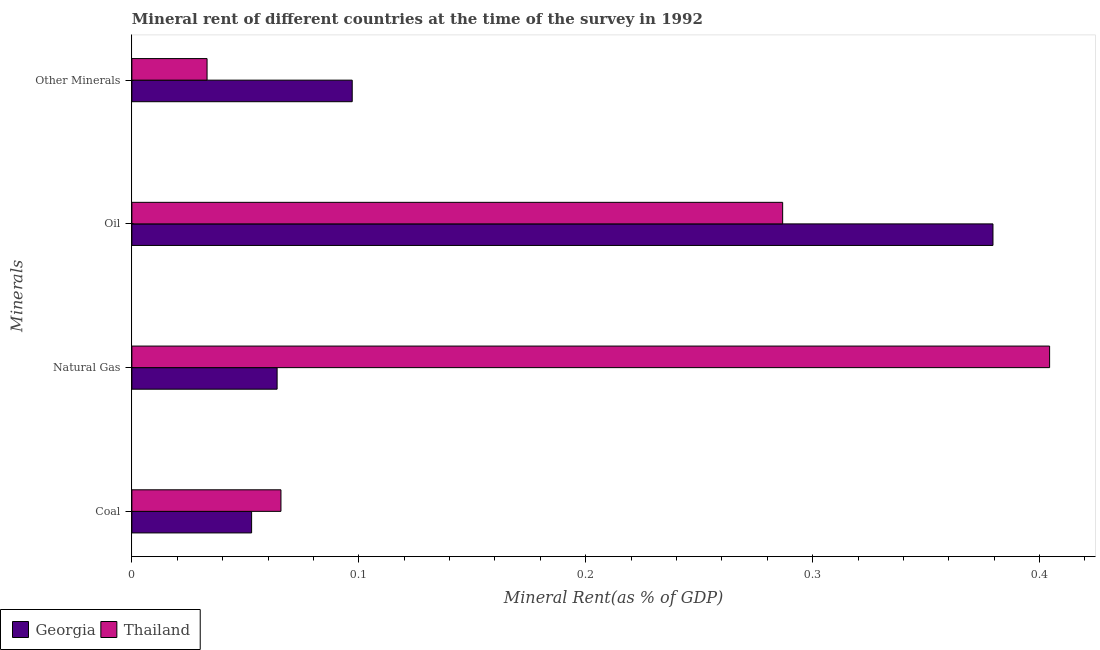How many different coloured bars are there?
Your answer should be very brief. 2. Are the number of bars per tick equal to the number of legend labels?
Make the answer very short. Yes. Are the number of bars on each tick of the Y-axis equal?
Provide a short and direct response. Yes. What is the label of the 2nd group of bars from the top?
Your answer should be very brief. Oil. What is the coal rent in Thailand?
Keep it short and to the point. 0.07. Across all countries, what is the maximum  rent of other minerals?
Your answer should be very brief. 0.1. Across all countries, what is the minimum natural gas rent?
Your answer should be compact. 0.06. In which country was the coal rent maximum?
Keep it short and to the point. Thailand. In which country was the  rent of other minerals minimum?
Your answer should be compact. Thailand. What is the total coal rent in the graph?
Your answer should be very brief. 0.12. What is the difference between the  rent of other minerals in Thailand and that in Georgia?
Keep it short and to the point. -0.06. What is the difference between the natural gas rent in Thailand and the  rent of other minerals in Georgia?
Make the answer very short. 0.31. What is the average  rent of other minerals per country?
Offer a very short reply. 0.07. What is the difference between the coal rent and natural gas rent in Thailand?
Offer a terse response. -0.34. What is the ratio of the oil rent in Thailand to that in Georgia?
Your answer should be compact. 0.76. Is the  rent of other minerals in Georgia less than that in Thailand?
Provide a short and direct response. No. What is the difference between the highest and the second highest  rent of other minerals?
Provide a short and direct response. 0.06. What is the difference between the highest and the lowest oil rent?
Offer a terse response. 0.09. In how many countries, is the oil rent greater than the average oil rent taken over all countries?
Your answer should be very brief. 1. Is the sum of the oil rent in Georgia and Thailand greater than the maximum coal rent across all countries?
Make the answer very short. Yes. Is it the case that in every country, the sum of the natural gas rent and oil rent is greater than the sum of  rent of other minerals and coal rent?
Give a very brief answer. No. What does the 1st bar from the top in Coal represents?
Provide a succinct answer. Thailand. What does the 2nd bar from the bottom in Coal represents?
Make the answer very short. Thailand. Is it the case that in every country, the sum of the coal rent and natural gas rent is greater than the oil rent?
Offer a terse response. No. Are the values on the major ticks of X-axis written in scientific E-notation?
Give a very brief answer. No. Does the graph contain any zero values?
Give a very brief answer. No. Does the graph contain grids?
Keep it short and to the point. No. How many legend labels are there?
Provide a short and direct response. 2. What is the title of the graph?
Keep it short and to the point. Mineral rent of different countries at the time of the survey in 1992. What is the label or title of the X-axis?
Keep it short and to the point. Mineral Rent(as % of GDP). What is the label or title of the Y-axis?
Offer a terse response. Minerals. What is the Mineral Rent(as % of GDP) of Georgia in Coal?
Provide a short and direct response. 0.05. What is the Mineral Rent(as % of GDP) of Thailand in Coal?
Make the answer very short. 0.07. What is the Mineral Rent(as % of GDP) in Georgia in Natural Gas?
Your response must be concise. 0.06. What is the Mineral Rent(as % of GDP) of Thailand in Natural Gas?
Keep it short and to the point. 0.4. What is the Mineral Rent(as % of GDP) of Georgia in Oil?
Your response must be concise. 0.38. What is the Mineral Rent(as % of GDP) of Thailand in Oil?
Your response must be concise. 0.29. What is the Mineral Rent(as % of GDP) of Georgia in Other Minerals?
Your answer should be very brief. 0.1. What is the Mineral Rent(as % of GDP) of Thailand in Other Minerals?
Give a very brief answer. 0.03. Across all Minerals, what is the maximum Mineral Rent(as % of GDP) in Georgia?
Offer a very short reply. 0.38. Across all Minerals, what is the maximum Mineral Rent(as % of GDP) in Thailand?
Provide a short and direct response. 0.4. Across all Minerals, what is the minimum Mineral Rent(as % of GDP) in Georgia?
Your answer should be very brief. 0.05. Across all Minerals, what is the minimum Mineral Rent(as % of GDP) in Thailand?
Ensure brevity in your answer.  0.03. What is the total Mineral Rent(as % of GDP) of Georgia in the graph?
Your response must be concise. 0.59. What is the total Mineral Rent(as % of GDP) in Thailand in the graph?
Provide a short and direct response. 0.79. What is the difference between the Mineral Rent(as % of GDP) of Georgia in Coal and that in Natural Gas?
Give a very brief answer. -0.01. What is the difference between the Mineral Rent(as % of GDP) of Thailand in Coal and that in Natural Gas?
Make the answer very short. -0.34. What is the difference between the Mineral Rent(as % of GDP) in Georgia in Coal and that in Oil?
Your response must be concise. -0.33. What is the difference between the Mineral Rent(as % of GDP) of Thailand in Coal and that in Oil?
Give a very brief answer. -0.22. What is the difference between the Mineral Rent(as % of GDP) in Georgia in Coal and that in Other Minerals?
Provide a succinct answer. -0.04. What is the difference between the Mineral Rent(as % of GDP) in Thailand in Coal and that in Other Minerals?
Give a very brief answer. 0.03. What is the difference between the Mineral Rent(as % of GDP) in Georgia in Natural Gas and that in Oil?
Your answer should be very brief. -0.32. What is the difference between the Mineral Rent(as % of GDP) of Thailand in Natural Gas and that in Oil?
Your response must be concise. 0.12. What is the difference between the Mineral Rent(as % of GDP) of Georgia in Natural Gas and that in Other Minerals?
Provide a short and direct response. -0.03. What is the difference between the Mineral Rent(as % of GDP) of Thailand in Natural Gas and that in Other Minerals?
Give a very brief answer. 0.37. What is the difference between the Mineral Rent(as % of GDP) of Georgia in Oil and that in Other Minerals?
Provide a short and direct response. 0.28. What is the difference between the Mineral Rent(as % of GDP) of Thailand in Oil and that in Other Minerals?
Your response must be concise. 0.25. What is the difference between the Mineral Rent(as % of GDP) of Georgia in Coal and the Mineral Rent(as % of GDP) of Thailand in Natural Gas?
Your response must be concise. -0.35. What is the difference between the Mineral Rent(as % of GDP) in Georgia in Coal and the Mineral Rent(as % of GDP) in Thailand in Oil?
Your response must be concise. -0.23. What is the difference between the Mineral Rent(as % of GDP) of Georgia in Coal and the Mineral Rent(as % of GDP) of Thailand in Other Minerals?
Keep it short and to the point. 0.02. What is the difference between the Mineral Rent(as % of GDP) of Georgia in Natural Gas and the Mineral Rent(as % of GDP) of Thailand in Oil?
Provide a succinct answer. -0.22. What is the difference between the Mineral Rent(as % of GDP) in Georgia in Natural Gas and the Mineral Rent(as % of GDP) in Thailand in Other Minerals?
Make the answer very short. 0.03. What is the difference between the Mineral Rent(as % of GDP) of Georgia in Oil and the Mineral Rent(as % of GDP) of Thailand in Other Minerals?
Offer a terse response. 0.35. What is the average Mineral Rent(as % of GDP) of Georgia per Minerals?
Your response must be concise. 0.15. What is the average Mineral Rent(as % of GDP) of Thailand per Minerals?
Provide a succinct answer. 0.2. What is the difference between the Mineral Rent(as % of GDP) of Georgia and Mineral Rent(as % of GDP) of Thailand in Coal?
Provide a short and direct response. -0.01. What is the difference between the Mineral Rent(as % of GDP) in Georgia and Mineral Rent(as % of GDP) in Thailand in Natural Gas?
Offer a terse response. -0.34. What is the difference between the Mineral Rent(as % of GDP) of Georgia and Mineral Rent(as % of GDP) of Thailand in Oil?
Make the answer very short. 0.09. What is the difference between the Mineral Rent(as % of GDP) of Georgia and Mineral Rent(as % of GDP) of Thailand in Other Minerals?
Provide a short and direct response. 0.06. What is the ratio of the Mineral Rent(as % of GDP) in Georgia in Coal to that in Natural Gas?
Ensure brevity in your answer.  0.82. What is the ratio of the Mineral Rent(as % of GDP) of Thailand in Coal to that in Natural Gas?
Provide a succinct answer. 0.16. What is the ratio of the Mineral Rent(as % of GDP) of Georgia in Coal to that in Oil?
Offer a very short reply. 0.14. What is the ratio of the Mineral Rent(as % of GDP) of Thailand in Coal to that in Oil?
Ensure brevity in your answer.  0.23. What is the ratio of the Mineral Rent(as % of GDP) of Georgia in Coal to that in Other Minerals?
Offer a very short reply. 0.54. What is the ratio of the Mineral Rent(as % of GDP) of Thailand in Coal to that in Other Minerals?
Your response must be concise. 1.98. What is the ratio of the Mineral Rent(as % of GDP) in Georgia in Natural Gas to that in Oil?
Give a very brief answer. 0.17. What is the ratio of the Mineral Rent(as % of GDP) of Thailand in Natural Gas to that in Oil?
Provide a short and direct response. 1.41. What is the ratio of the Mineral Rent(as % of GDP) in Georgia in Natural Gas to that in Other Minerals?
Offer a terse response. 0.66. What is the ratio of the Mineral Rent(as % of GDP) in Thailand in Natural Gas to that in Other Minerals?
Offer a terse response. 12.21. What is the ratio of the Mineral Rent(as % of GDP) of Georgia in Oil to that in Other Minerals?
Your response must be concise. 3.91. What is the ratio of the Mineral Rent(as % of GDP) in Thailand in Oil to that in Other Minerals?
Give a very brief answer. 8.66. What is the difference between the highest and the second highest Mineral Rent(as % of GDP) of Georgia?
Provide a short and direct response. 0.28. What is the difference between the highest and the second highest Mineral Rent(as % of GDP) of Thailand?
Provide a succinct answer. 0.12. What is the difference between the highest and the lowest Mineral Rent(as % of GDP) of Georgia?
Your answer should be very brief. 0.33. What is the difference between the highest and the lowest Mineral Rent(as % of GDP) of Thailand?
Provide a succinct answer. 0.37. 